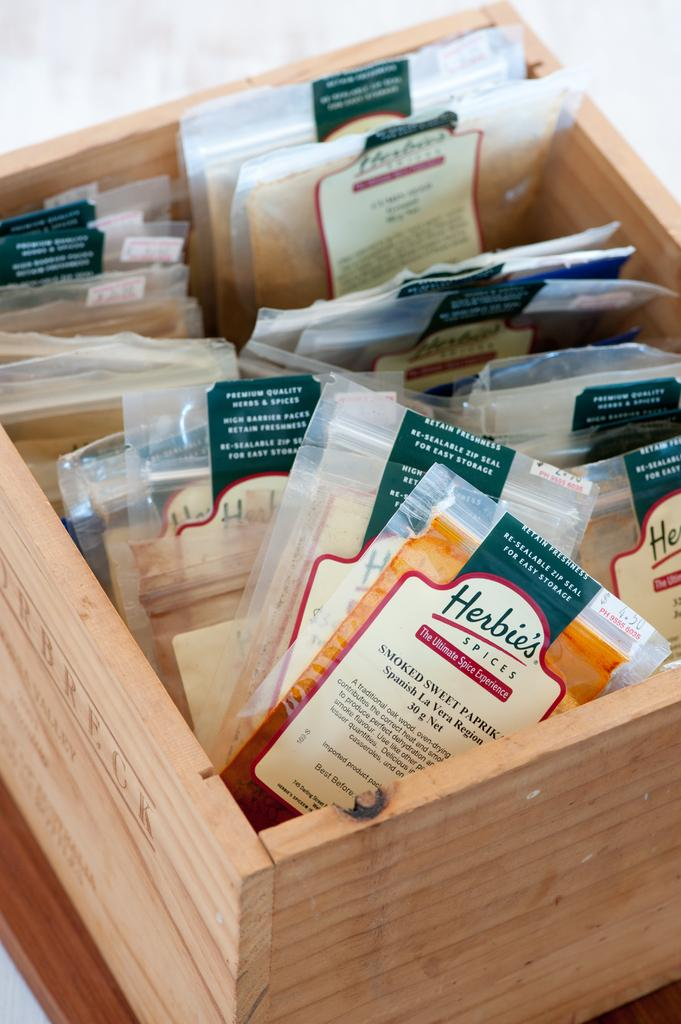<image>
Summarize the visual content of the image. A wooden container is full of different kinds of Herbie's Spices. 